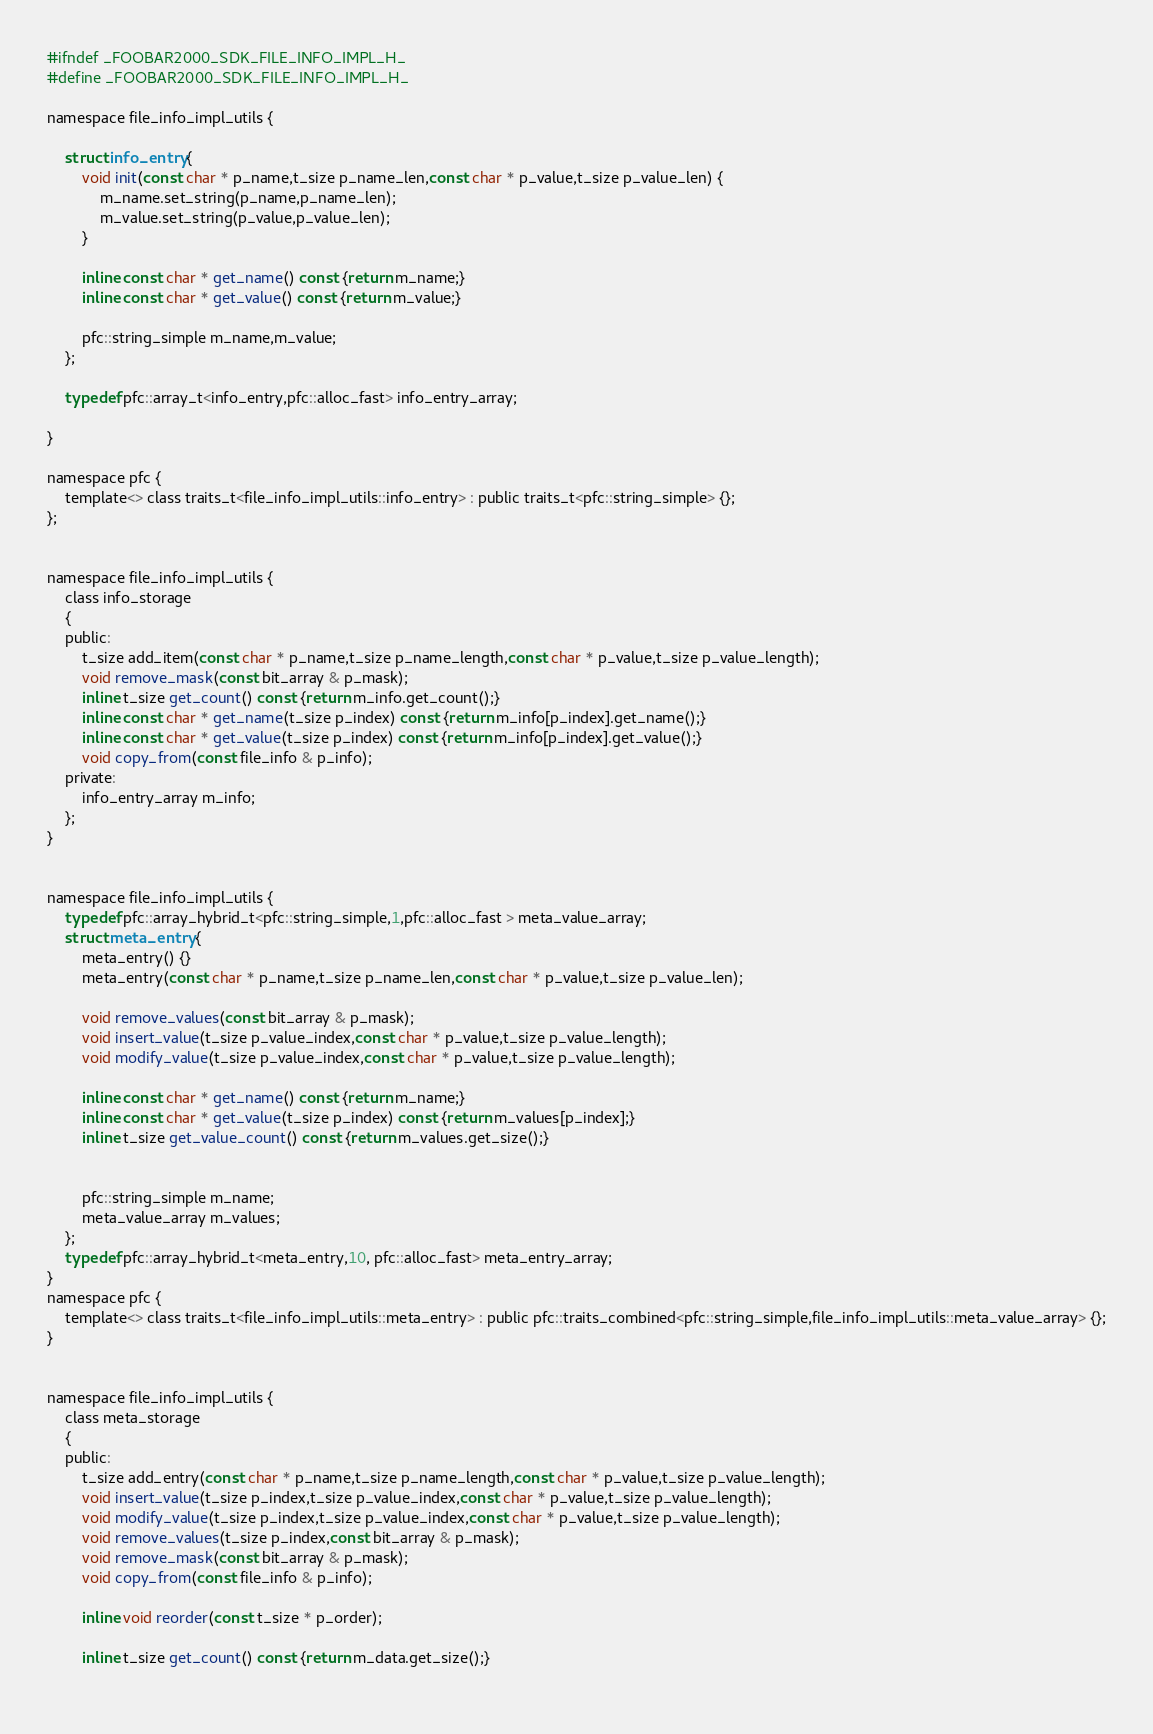<code> <loc_0><loc_0><loc_500><loc_500><_C_>#ifndef _FOOBAR2000_SDK_FILE_INFO_IMPL_H_
#define _FOOBAR2000_SDK_FILE_INFO_IMPL_H_

namespace file_info_impl_utils {

	struct info_entry {
		void init(const char * p_name,t_size p_name_len,const char * p_value,t_size p_value_len) {
			m_name.set_string(p_name,p_name_len);
			m_value.set_string(p_value,p_value_len);
		}
		
		inline const char * get_name() const {return m_name;}
		inline const char * get_value() const {return m_value;}

		pfc::string_simple m_name,m_value;
	};

	typedef pfc::array_t<info_entry,pfc::alloc_fast> info_entry_array;

}

namespace pfc {
	template<> class traits_t<file_info_impl_utils::info_entry> : public traits_t<pfc::string_simple> {};
};


namespace file_info_impl_utils {
	class info_storage
	{
	public:
		t_size add_item(const char * p_name,t_size p_name_length,const char * p_value,t_size p_value_length);
		void remove_mask(const bit_array & p_mask);	
		inline t_size get_count() const {return m_info.get_count();}
		inline const char * get_name(t_size p_index) const {return m_info[p_index].get_name();}
		inline const char * get_value(t_size p_index) const {return m_info[p_index].get_value();}
		void copy_from(const file_info & p_info);
	private:
		info_entry_array m_info;
	};
}


namespace file_info_impl_utils {
	typedef pfc::array_hybrid_t<pfc::string_simple,1,pfc::alloc_fast > meta_value_array;
	struct meta_entry {
		meta_entry() {}
		meta_entry(const char * p_name,t_size p_name_len,const char * p_value,t_size p_value_len);

		void remove_values(const bit_array & p_mask);
		void insert_value(t_size p_value_index,const char * p_value,t_size p_value_length);
		void modify_value(t_size p_value_index,const char * p_value,t_size p_value_length);

		inline const char * get_name() const {return m_name;}
		inline const char * get_value(t_size p_index) const {return m_values[p_index];}
		inline t_size get_value_count() const {return m_values.get_size();}
		

		pfc::string_simple m_name;
		meta_value_array m_values;
	};
	typedef pfc::array_hybrid_t<meta_entry,10, pfc::alloc_fast> meta_entry_array;
}
namespace pfc {
	template<> class traits_t<file_info_impl_utils::meta_entry> : public pfc::traits_combined<pfc::string_simple,file_info_impl_utils::meta_value_array> {};
}


namespace file_info_impl_utils {
	class meta_storage
	{
	public:
		t_size add_entry(const char * p_name,t_size p_name_length,const char * p_value,t_size p_value_length);
		void insert_value(t_size p_index,t_size p_value_index,const char * p_value,t_size p_value_length);
		void modify_value(t_size p_index,t_size p_value_index,const char * p_value,t_size p_value_length);
		void remove_values(t_size p_index,const bit_array & p_mask);
		void remove_mask(const bit_array & p_mask);
		void copy_from(const file_info & p_info);

		inline void reorder(const t_size * p_order);

		inline t_size get_count() const {return m_data.get_size();}
		</code> 